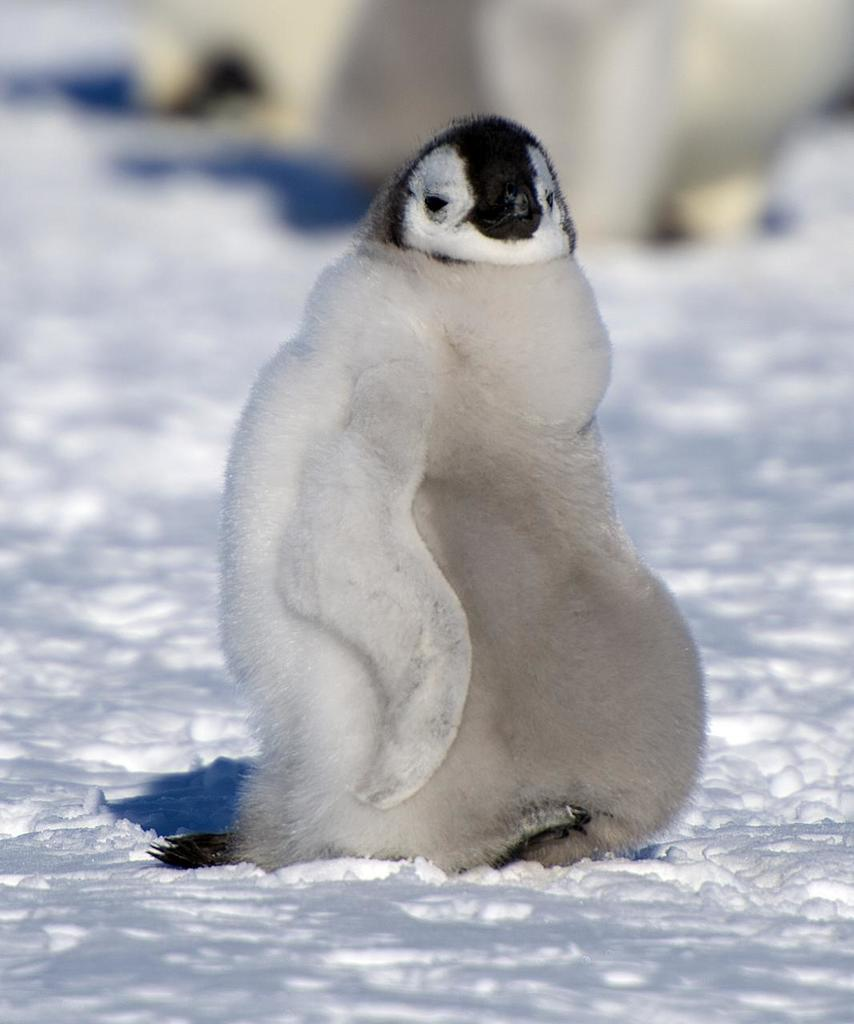What animal is present in the image? There is a penguin in the image. What type of terrain is the penguin standing on? The penguin is on the snow. Can you describe the background of the image? The background of the image is blurred. How many beds can be seen in the image? There are no beds present in the image; it features a penguin on the snow with a blurred background. 